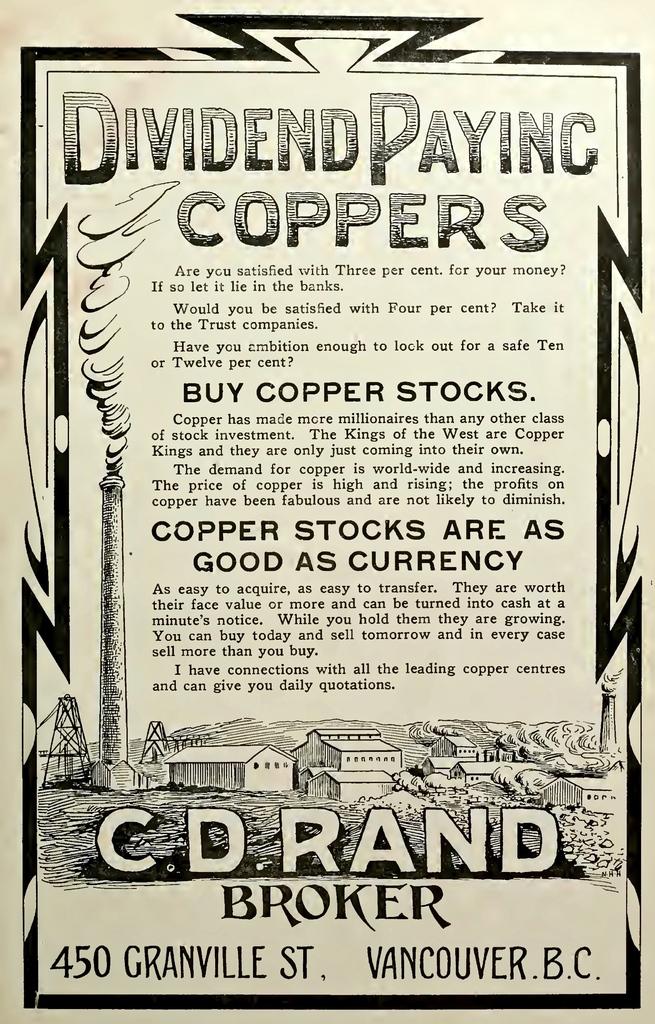What location is listed at the bottom of the flyer?
Your answer should be very brief. Vancouver b.c. 